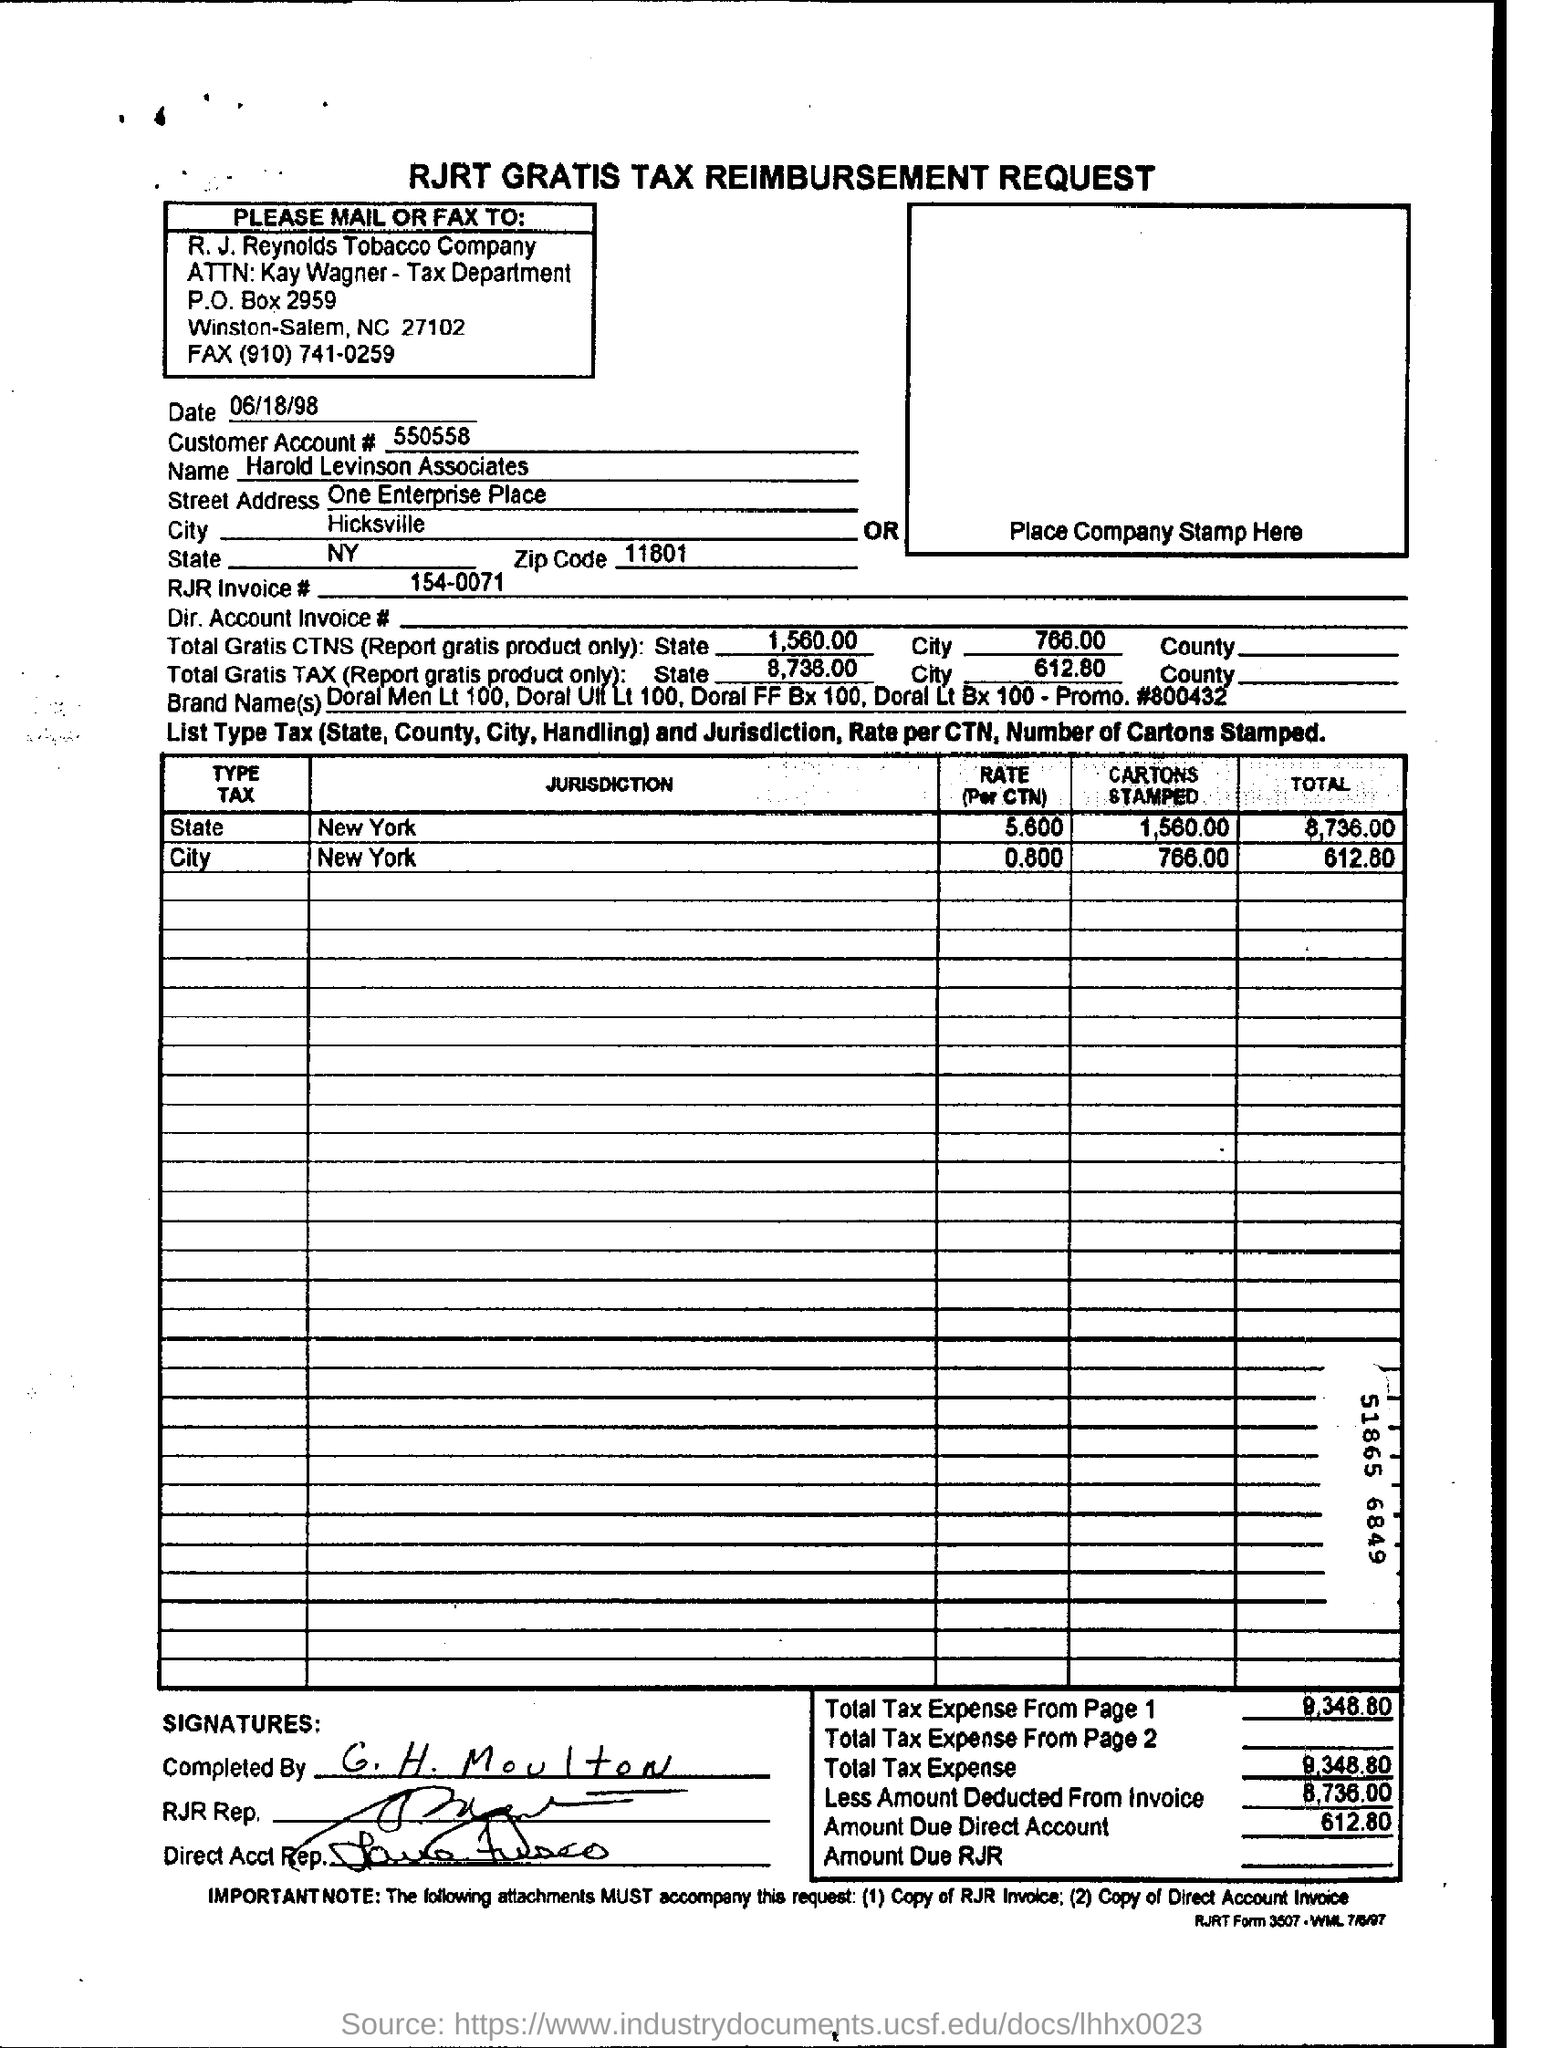Specify some key components in this picture. The amount due on the direct account is $612.80. The document is called 'RJRT GRATIS TAX REIMBURSEMENT REQUEST.' In New York State, approximately 1,560 cartons are stamped every month. The Tax reimbursement request has been completed by G. H. Moulton. The customer name is Harold Levinson Associates. 